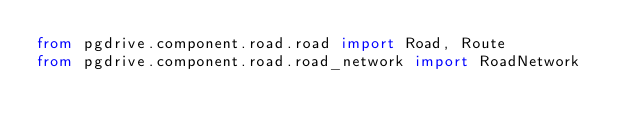<code> <loc_0><loc_0><loc_500><loc_500><_Python_>from pgdrive.component.road.road import Road, Route
from pgdrive.component.road.road_network import RoadNetwork
</code> 